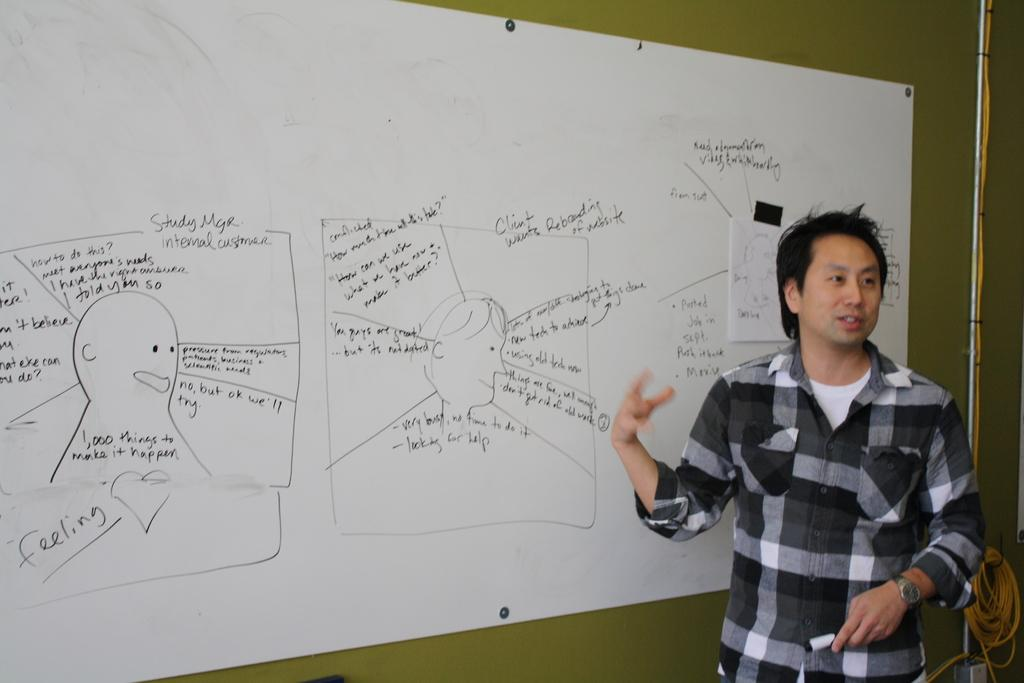<image>
Share a concise interpretation of the image provided. Man standing in front of a board that says Internal Customer on it. 